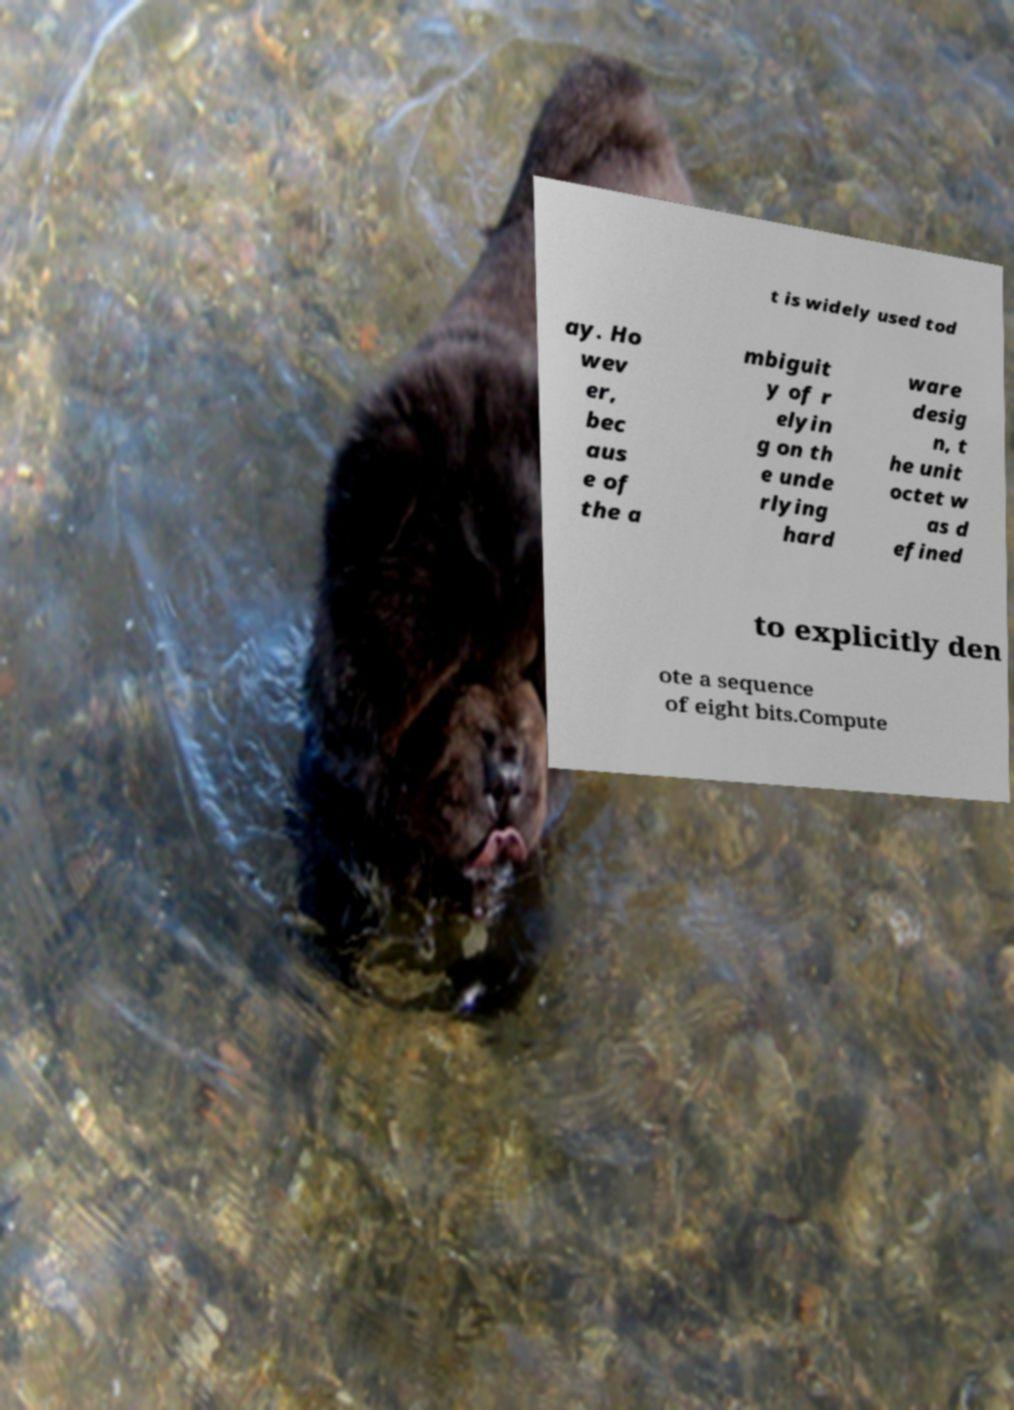Could you extract and type out the text from this image? t is widely used tod ay. Ho wev er, bec aus e of the a mbiguit y of r elyin g on th e unde rlying hard ware desig n, t he unit octet w as d efined to explicitly den ote a sequence of eight bits.Compute 